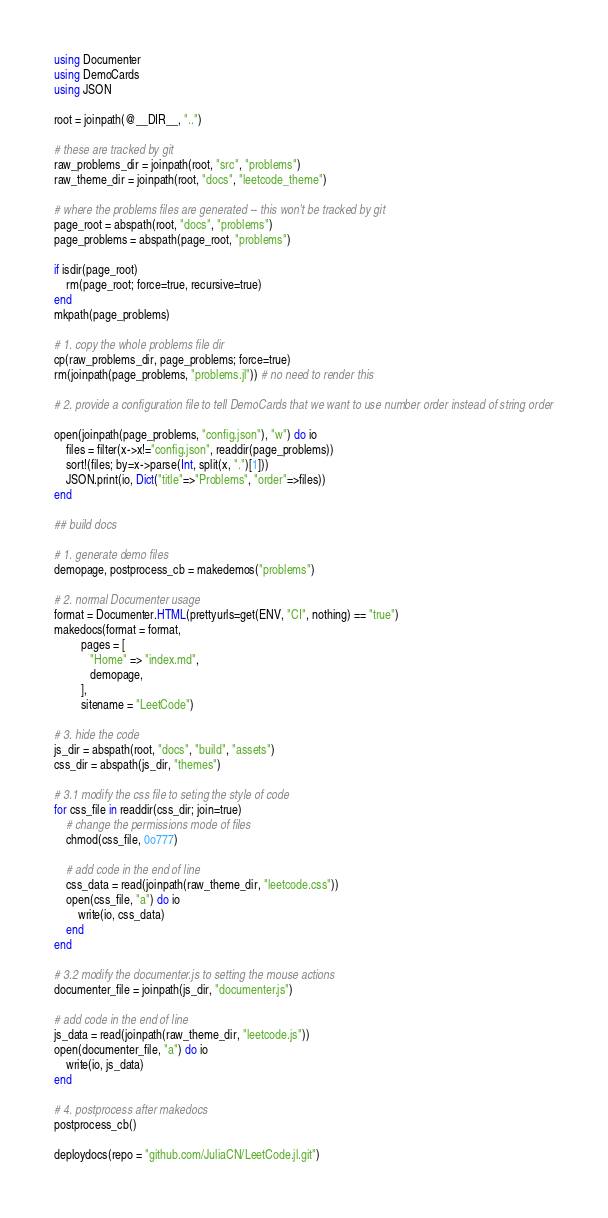Convert code to text. <code><loc_0><loc_0><loc_500><loc_500><_Julia_>using Documenter
using DemoCards
using JSON

root = joinpath(@__DIR__, "..")

# these are tracked by git
raw_problems_dir = joinpath(root, "src", "problems")
raw_theme_dir = joinpath(root, "docs", "leetcode_theme")

# where the problems files are generated -- this won't be tracked by git
page_root = abspath(root, "docs", "problems")
page_problems = abspath(page_root, "problems")

if isdir(page_root)
    rm(page_root; force=true, recursive=true)
end
mkpath(page_problems)

# 1. copy the whole problems file dir
cp(raw_problems_dir, page_problems; force=true)
rm(joinpath(page_problems, "problems.jl")) # no need to render this

# 2. provide a configuration file to tell DemoCards that we want to use number order instead of string order

open(joinpath(page_problems, "config.json"), "w") do io
    files = filter(x->x!="config.json", readdir(page_problems))
    sort!(files; by=x->parse(Int, split(x, ".")[1]))
    JSON.print(io, Dict("title"=>"Problems", "order"=>files))
end

## build docs

# 1. generate demo files
demopage, postprocess_cb = makedemos("problems")

# 2. normal Documenter usage
format = Documenter.HTML(prettyurls=get(ENV, "CI", nothing) == "true")
makedocs(format = format,
         pages = [
            "Home" => "index.md",
            demopage,
         ],
         sitename = "LeetCode")

# 3. hide the code
js_dir = abspath(root, "docs", "build", "assets")
css_dir = abspath(js_dir, "themes")

# 3.1 modify the css file to seting the style of code
for css_file in readdir(css_dir; join=true)
    # change the permissions mode of files
    chmod(css_file, 0o777)

    # add code in the end of line
    css_data = read(joinpath(raw_theme_dir, "leetcode.css"))
    open(css_file, "a") do io
        write(io, css_data)
    end
end

# 3.2 modify the documenter.js to setting the mouse actions
documenter_file = joinpath(js_dir, "documenter.js")

# add code in the end of line
js_data = read(joinpath(raw_theme_dir, "leetcode.js"))
open(documenter_file, "a") do io
    write(io, js_data)
end 

# 4. postprocess after makedocs
postprocess_cb()

deploydocs(repo = "github.com/JuliaCN/LeetCode.jl.git")</code> 